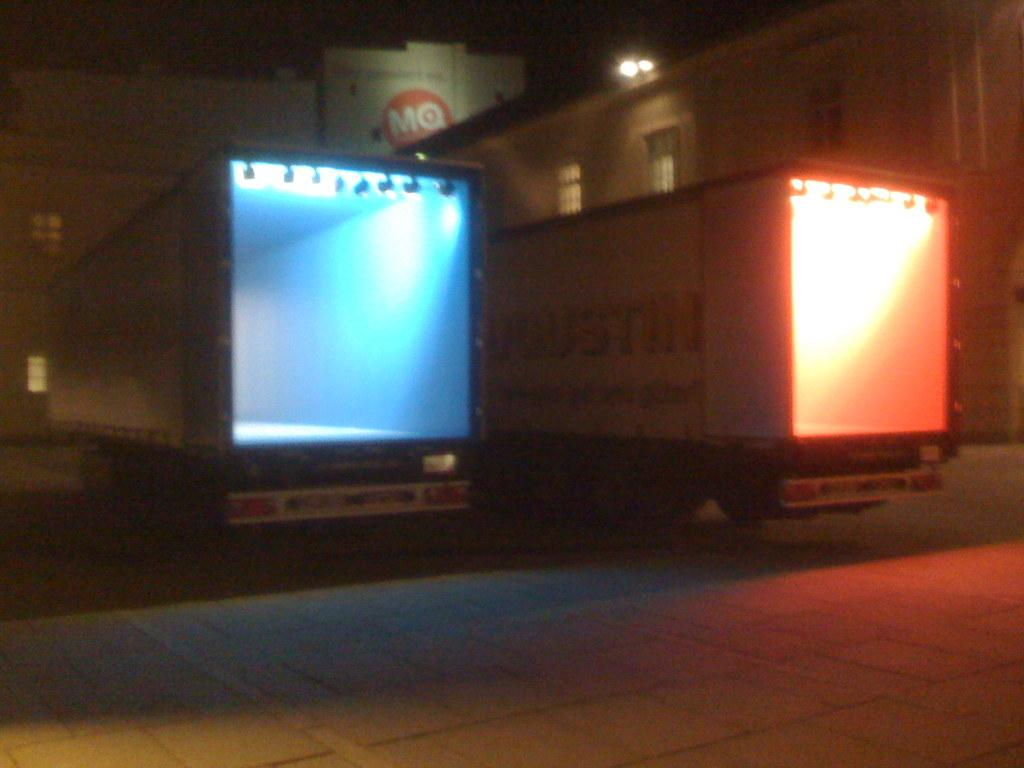What can be seen in the center of the image? There are two vehicles in the center of the image. What is visible in the background of the image? There are buildings and lights in the background of the image. What is at the bottom of the image? There is a walkway at the bottom of the image. Where is the hydrant located in the image? There is no hydrant present in the image. What type of shock can be seen in the image? There is no shock present in the image. 